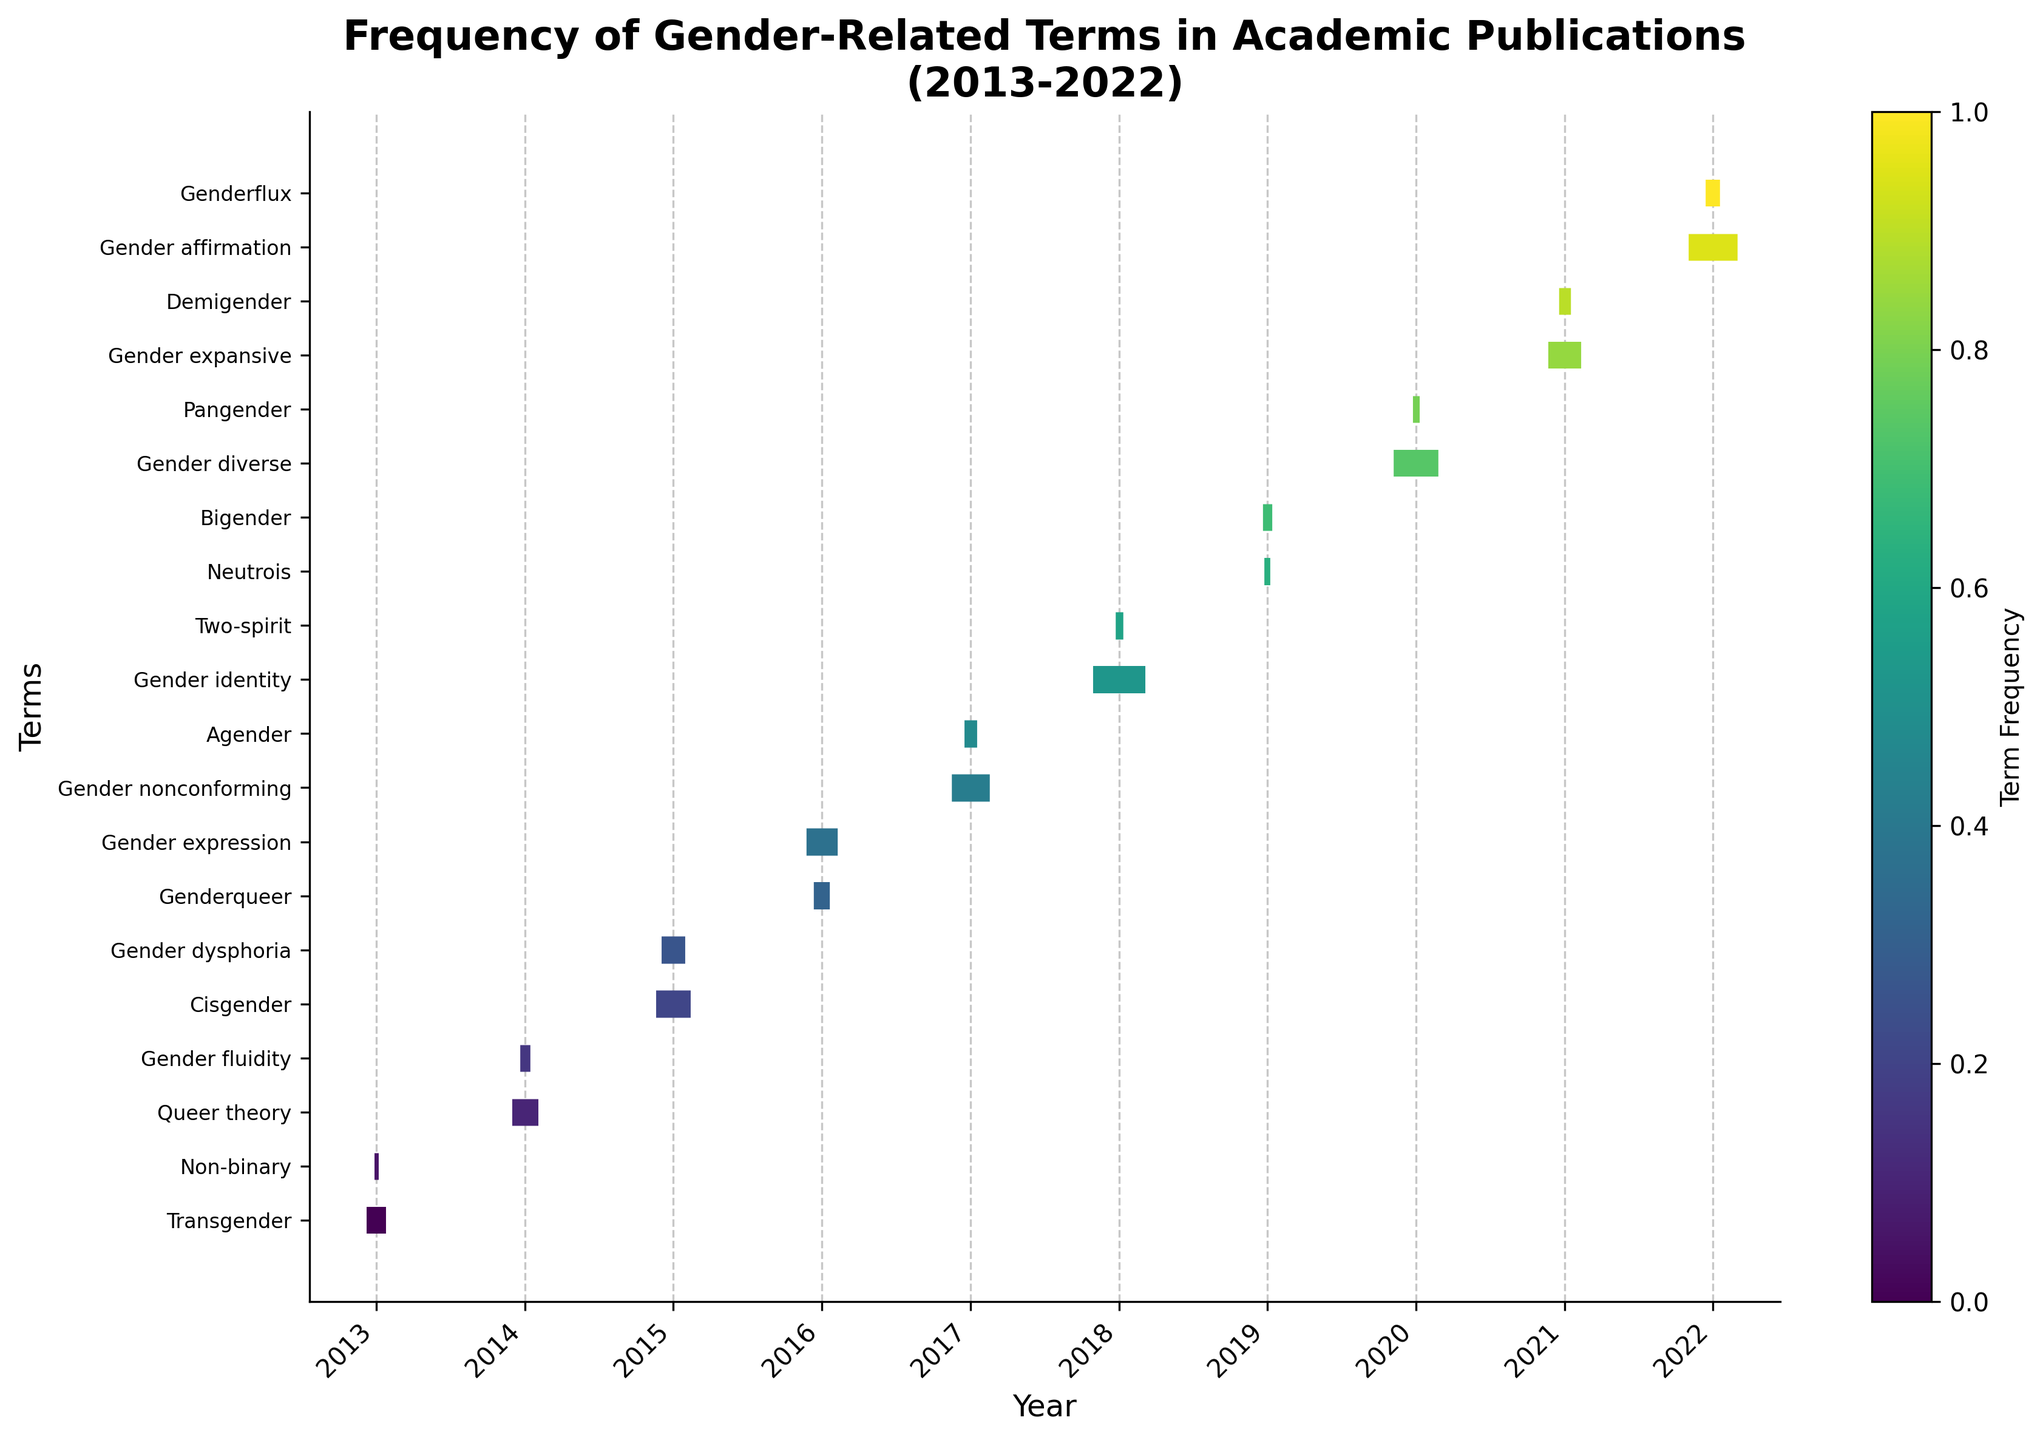Which year saw the highest frequency of usage for the term "Gender identity"? The term "Gender identity" appears to have its data point in 2018. By looking at the thickness of the line corresponding to this term, we can see that it has a frequency of 62, making it the highest in that year compared to other data points.
Answer: 2018 Which terms appeared in 2020 and what are their frequencies? The terms that appeared in 2020 are "Gender diverse" and "Pangender". The eventplot indicates their frequencies through the thickness of the lines: "Gender diverse" has a frequency of 53 and "Pangender" has a frequency of 8.
Answer: Gender diverse (53), Pangender (8) Compare the frequency of "Cisgender" in 2015 to "Gender affirmation" in 2022. Which one is higher, and by how much? In the eventplot, the term "Cisgender" in 2015 shows a frequency of 41, while "Gender affirmation" in 2022 shows a frequency of 58. Comparing these, "Gender affirmation" has a higher frequency by 58 - 41 = 17.
Answer: Gender affirmation is 17 higher What is the average frequency of terms in 2016? In 2016, the terms are "Genderqueer" and "Gender expression". Their frequencies are 19 and 37 respectively. To find the average, we sum these frequencies and divide by the number of terms: (19 + 37) / 2 = 28.
Answer: 28 How does the frequency of terms in 2021 compare to those in 2014? In 2021, "Gender expansive" has a frequency of 39 and "Demigender" has 14; summing these up gives 39 + 14 = 53. In 2014, "Queer theory" has a frequency of 31 and "Gender fluidity" has 12; summing these up gives 31 + 12 = 43. Therefore, the total frequency in 2021 (53) is higher than in 2014 (43).
Answer: 2021 is higher by 10 Which term has the lowest overall frequency, and in what year did it appear? By examining the thickness of the lines corresponding to each term, "Neutrois" in 2019 appears to have the thinnest line, indicating the lowest frequency of 7.
Answer: Neutrois (2019) Which year had the most diverse set of terms represented, and how many terms were there? To determine this, we count the unique terms for each year. The year with the most unique terms is 2014 with the terms "Queer theory" and "Gender fluidity", but this only amounts to 2 terms. Similarly, 2016 also had 2 terms, and other years either match or have fewer. Thus, multiple years have the maximum count of terms, which is 2 terms per year.
Answer: 2014 and 2016 (2 terms each) How many terms have more than 50 occurrences in any given year? Observing the plot, "Gender identity" in 2018 has 62 occurrences, "Gender diverse" in 2020 has 53 occurrences, and "Gender affirmation" in 2022 has 58 occurrences. These are the terms with more than 50 occurrences.
Answer: 3 terms 